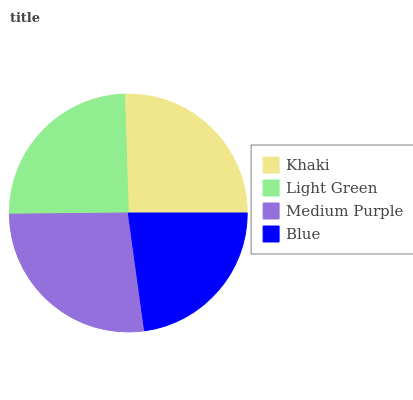Is Blue the minimum?
Answer yes or no. Yes. Is Medium Purple the maximum?
Answer yes or no. Yes. Is Light Green the minimum?
Answer yes or no. No. Is Light Green the maximum?
Answer yes or no. No. Is Khaki greater than Light Green?
Answer yes or no. Yes. Is Light Green less than Khaki?
Answer yes or no. Yes. Is Light Green greater than Khaki?
Answer yes or no. No. Is Khaki less than Light Green?
Answer yes or no. No. Is Khaki the high median?
Answer yes or no. Yes. Is Light Green the low median?
Answer yes or no. Yes. Is Blue the high median?
Answer yes or no. No. Is Khaki the low median?
Answer yes or no. No. 